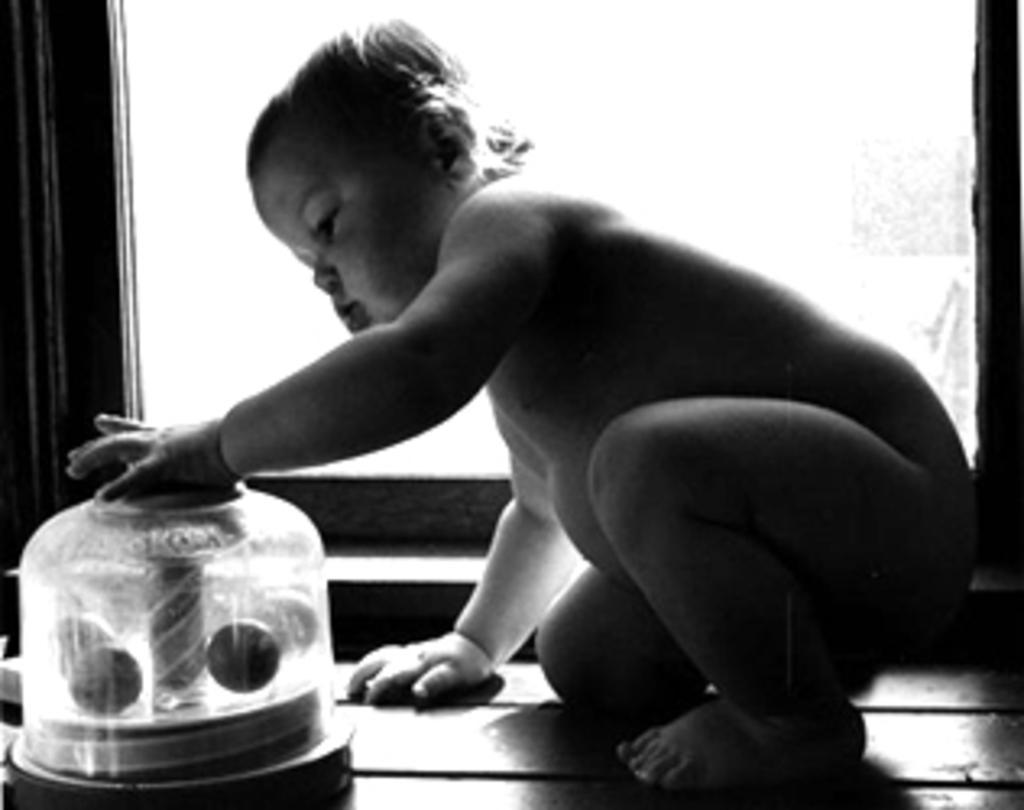Please provide a concise description of this image. In this image there is a child, there is an object truncated towards the bottom of the image, at the background of the image there is a window truncated. 